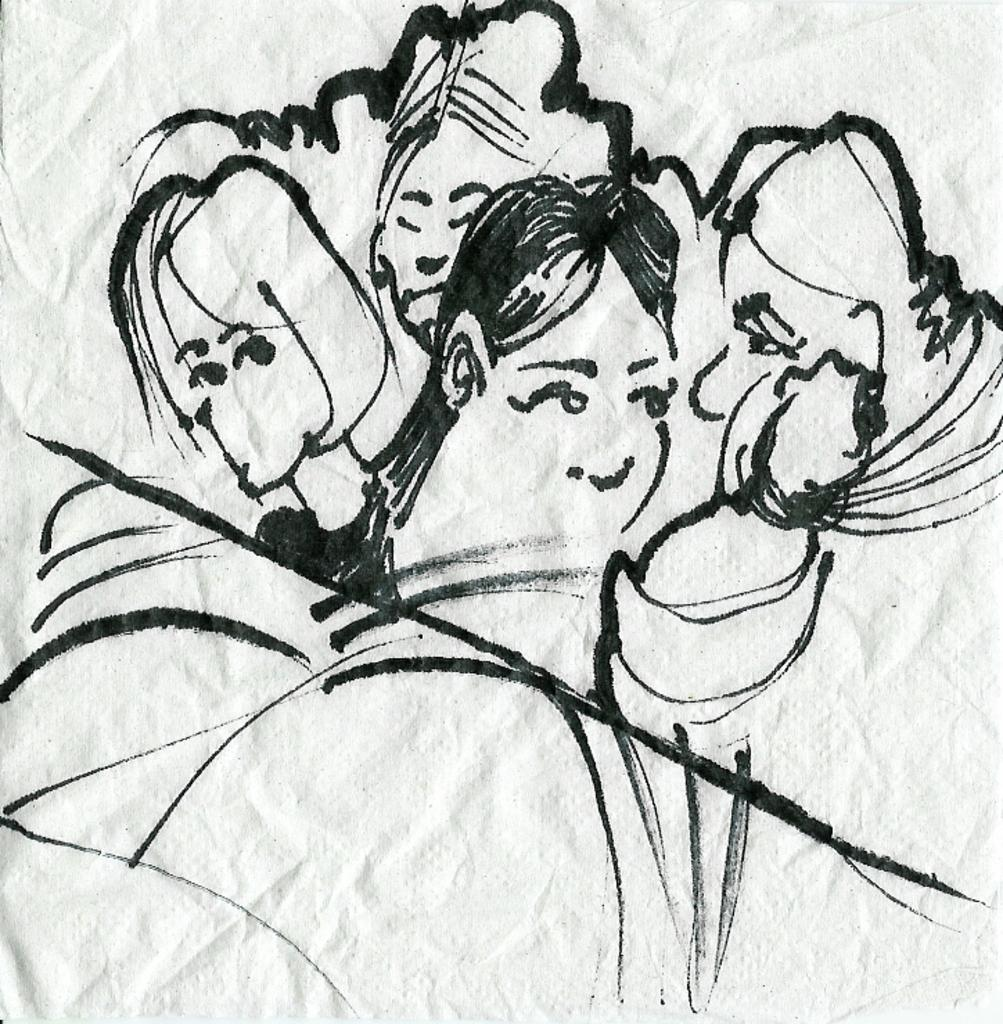What is depicted on the wall in the image? There is wall graffiti or a sketch in the image. What is the color of the wall on which the graffiti or sketch is drawn? The graffiti or sketch is drawn on a white wall. Who is the ornament in the image? There is no ornament present in the image. Can you tell me the name of the creator of the graffiti or sketch in the image? The image does not provide information about the creator of the graffiti or sketch. 